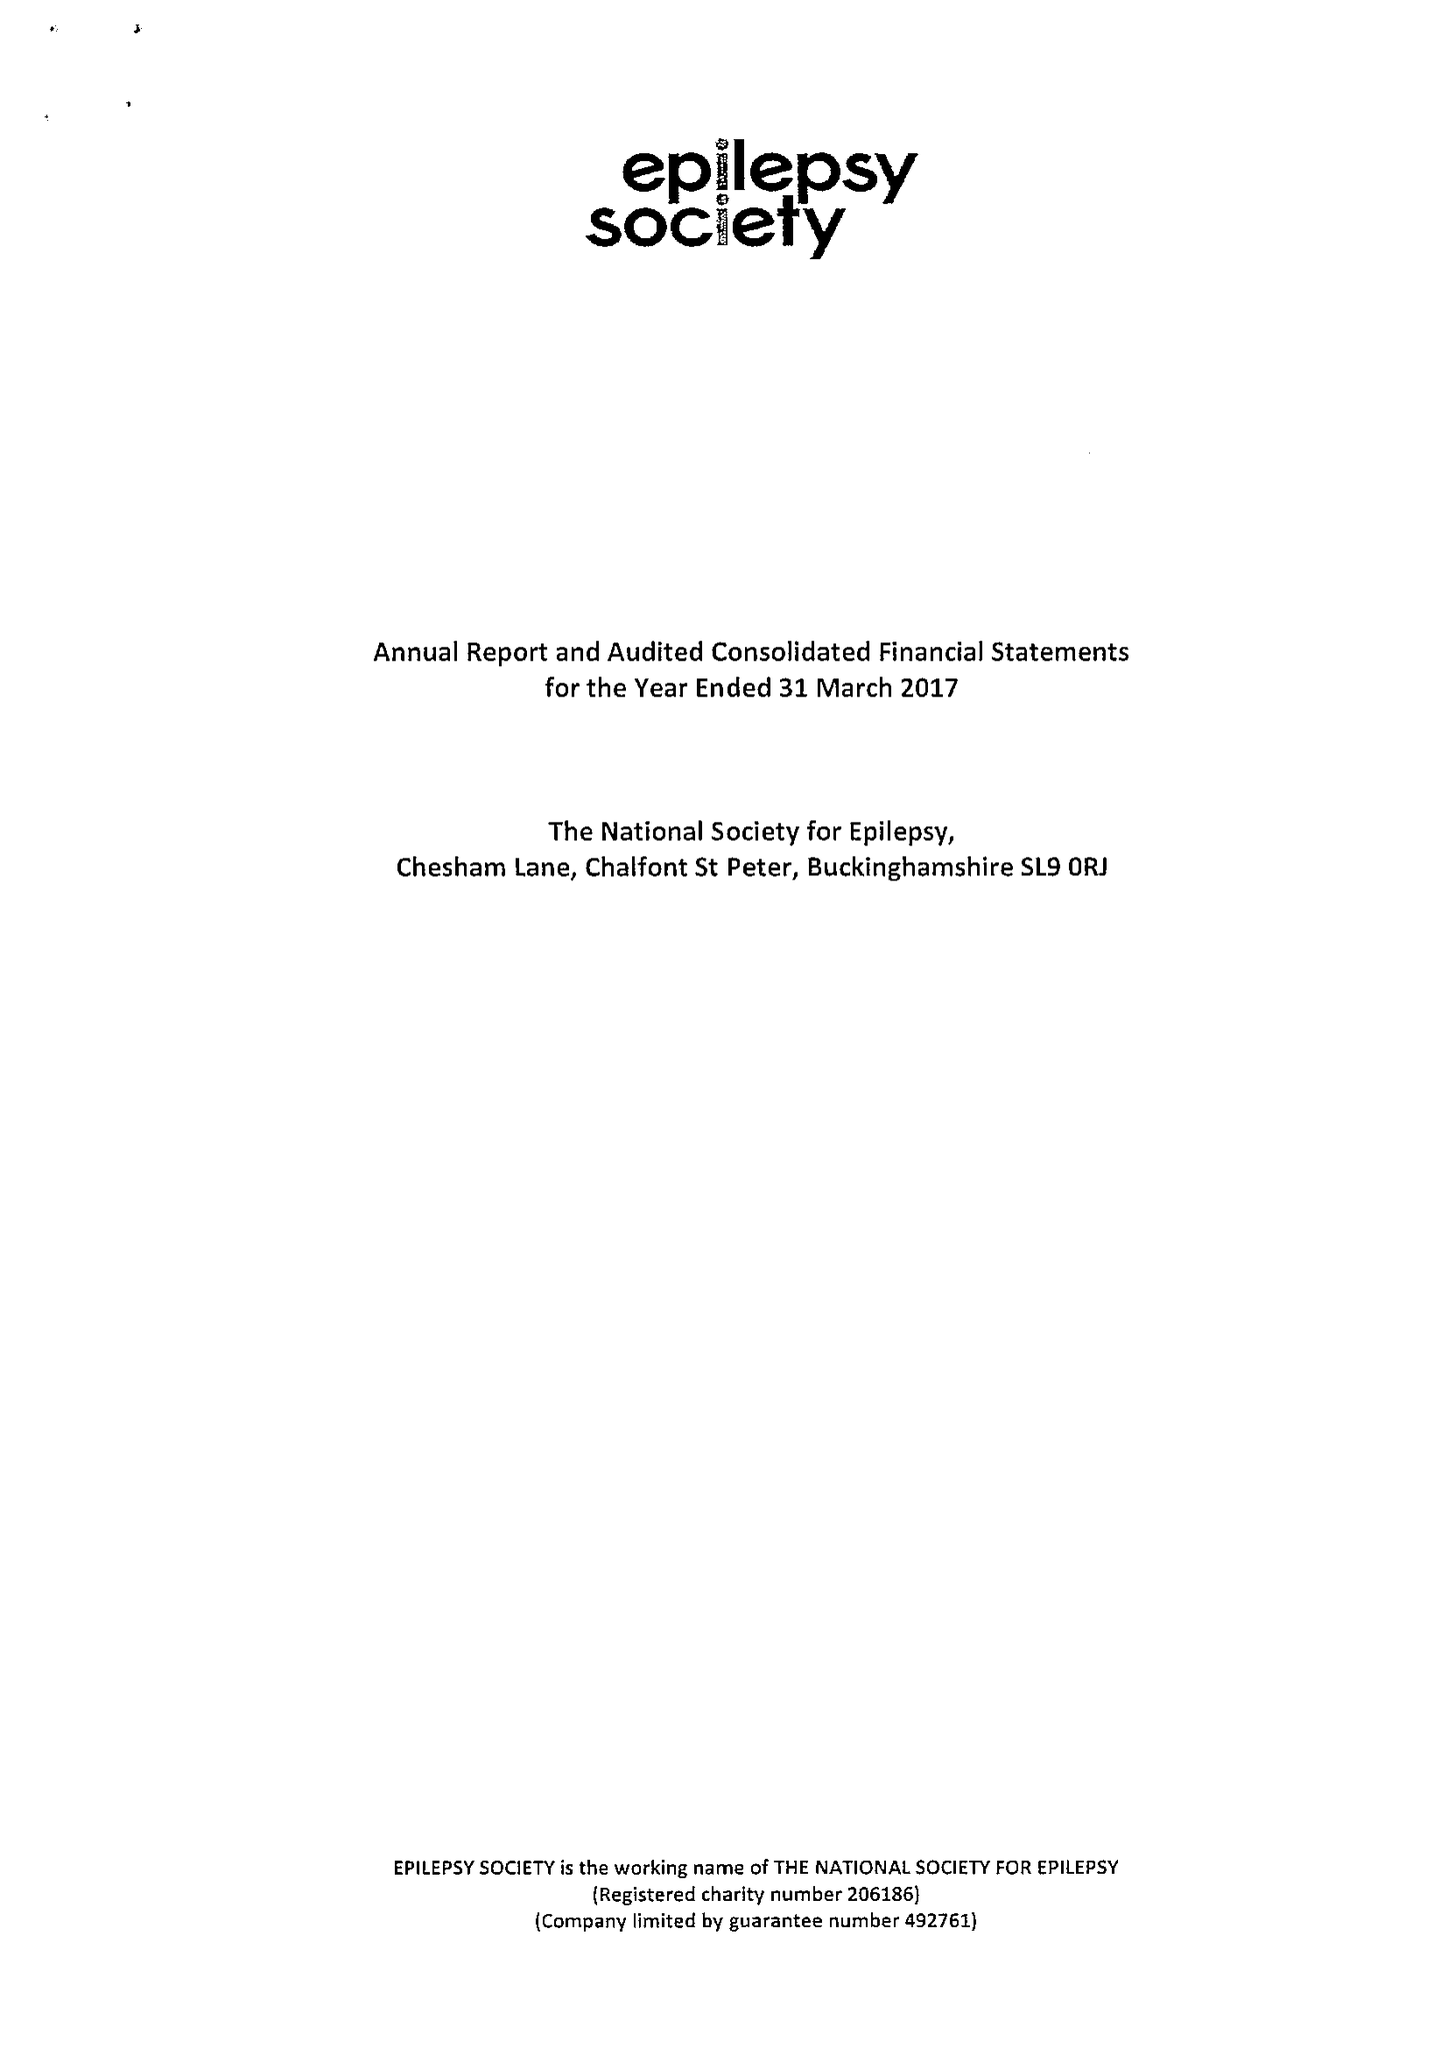What is the value for the spending_annually_in_british_pounds?
Answer the question using a single word or phrase. 16841000.00 